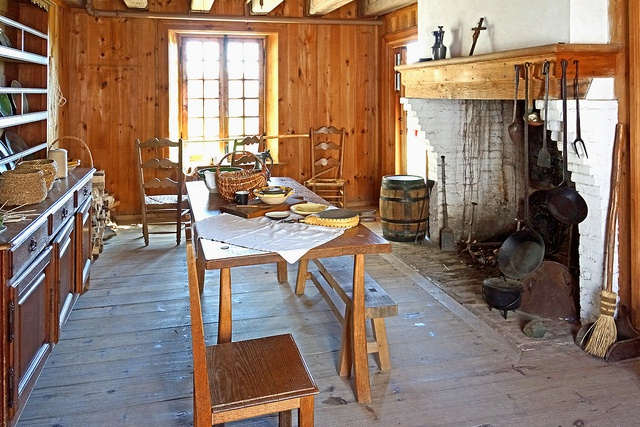Describe the objects in this image and their specific colors. I can see dining table in olive, lightgray, gray, darkgray, and brown tones, chair in olive, maroon, red, and tan tones, chair in olive, maroon, brown, and white tones, chair in olive, brown, maroon, salmon, and tan tones, and bowl in olive, khaki, maroon, gray, and tan tones in this image. 